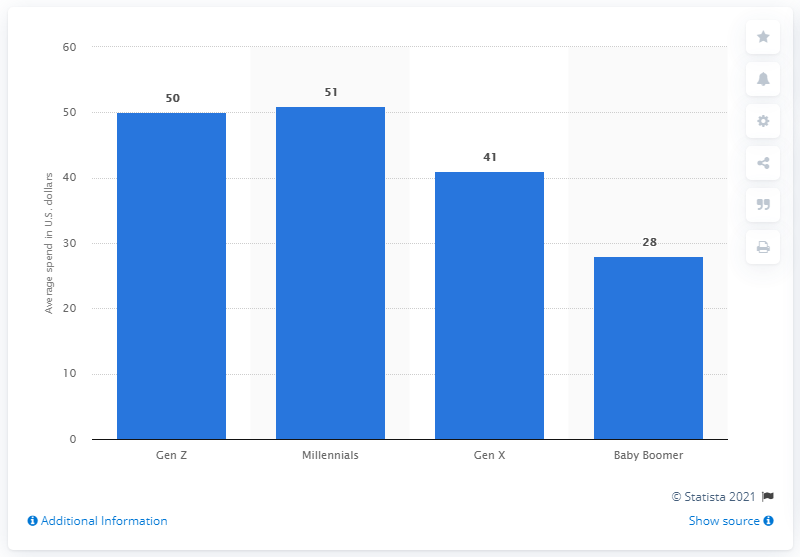How does this information help pet-related businesses in their marketing strategies? This information can help pet-related businesses tailor their marketing strategies by targeting specific generational groups. For instance, companies may focus on Millennials with premium pet products or special holiday offers, given their tendency to spend more on average. Marketing campaigns can be customized based on these spending habits to maximize engagement and sales. 